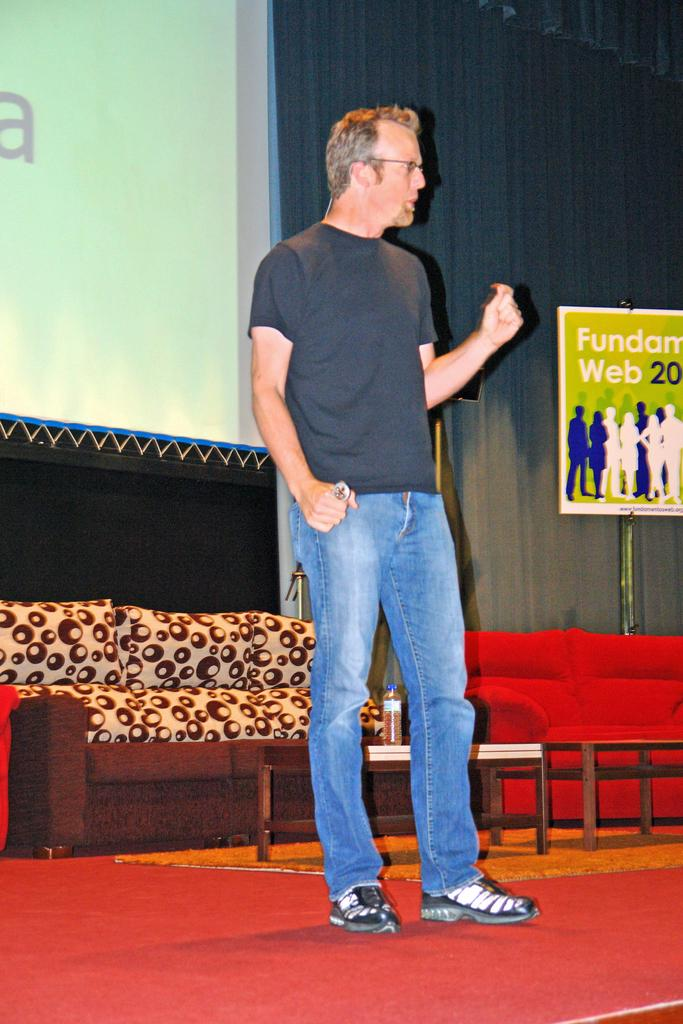What is the person on the stage doing? The person is standing on the stage and holding an object. What type of furniture is present in the image? There are sofas in the image. Can you describe any other objects on the tables? There is a bottle on one of the tables. What is attached to the wall in the image? There is a poster attached to the wall. What is displayed on the screen in the image? There is a screen with text in the image. What role does the person's brother play in the war depicted in the image? There is no war depicted in the image, and the person's brother is not mentioned. How many feet are visible in the image? There is no reference to feet or any body parts in the image. 